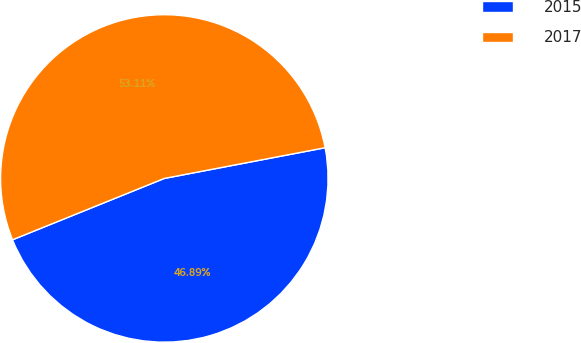Convert chart to OTSL. <chart><loc_0><loc_0><loc_500><loc_500><pie_chart><fcel>2015<fcel>2017<nl><fcel>46.89%<fcel>53.11%<nl></chart> 